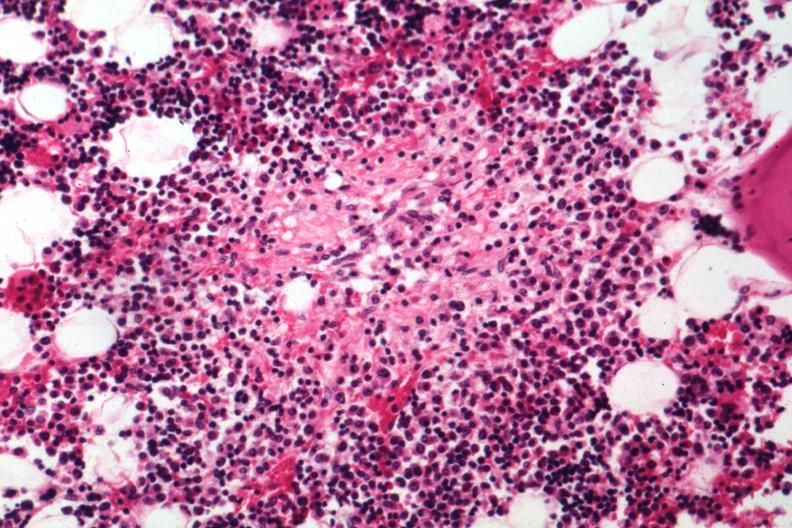s ameloblastoma present?
Answer the question using a single word or phrase. No 